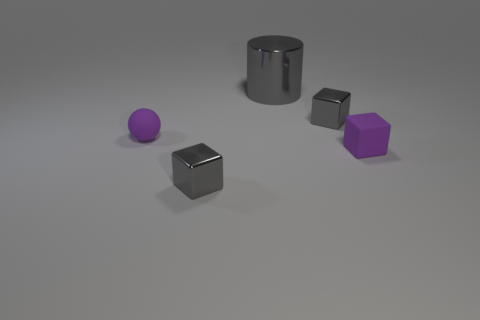What material is the small block that is the same color as the tiny matte sphere?
Make the answer very short. Rubber. Are there more matte things that are right of the large metal cylinder than small gray metallic objects?
Provide a succinct answer. No. What number of purple blocks have the same material as the tiny purple ball?
Offer a very short reply. 1. Does the gray cylinder have the same size as the rubber sphere?
Your answer should be very brief. No. There is a tiny gray shiny object that is in front of the gray shiny cube behind the gray cube in front of the purple matte block; what shape is it?
Provide a succinct answer. Cube. There is a metallic thing that is both in front of the big cylinder and behind the tiny matte block; what size is it?
Offer a very short reply. Small. There is a gray cube that is right of the gray metallic cube in front of the ball; what number of large gray objects are in front of it?
Ensure brevity in your answer.  0. How many small objects are gray shiny cubes or cylinders?
Ensure brevity in your answer.  2. Is the material of the gray object in front of the small matte ball the same as the small purple ball?
Offer a very short reply. No. There is a tiny cube behind the tiny purple rubber cube that is behind the metallic cube in front of the matte sphere; what is it made of?
Your answer should be compact. Metal. 